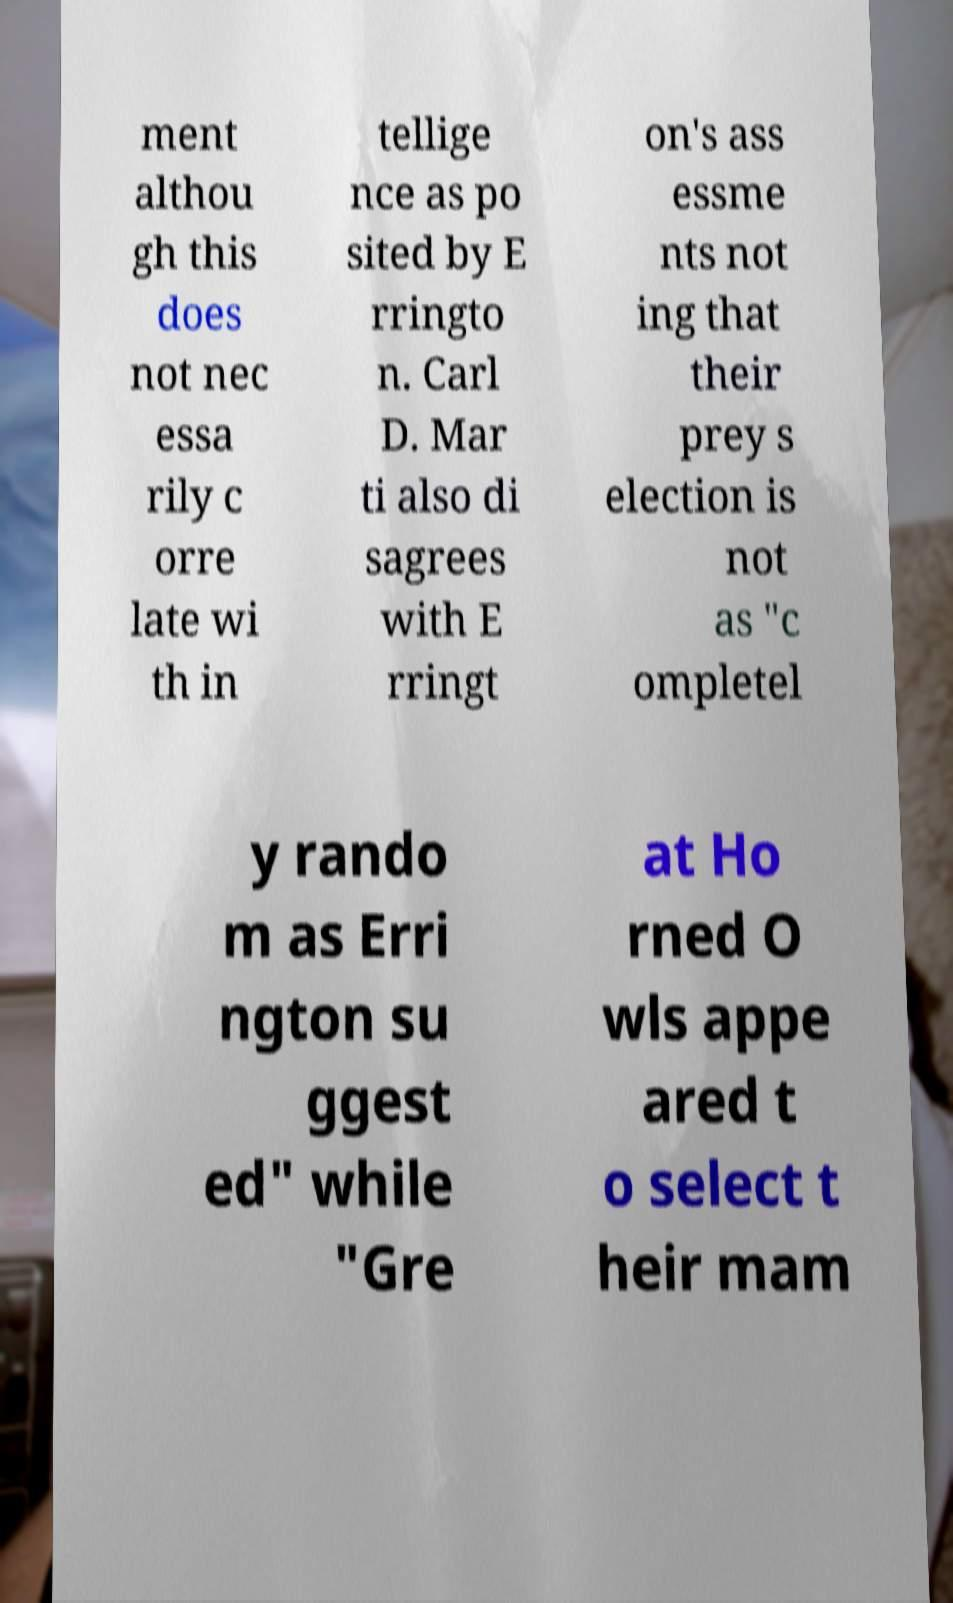I need the written content from this picture converted into text. Can you do that? ment althou gh this does not nec essa rily c orre late wi th in tellige nce as po sited by E rringto n. Carl D. Mar ti also di sagrees with E rringt on's ass essme nts not ing that their prey s election is not as "c ompletel y rando m as Erri ngton su ggest ed" while "Gre at Ho rned O wls appe ared t o select t heir mam 